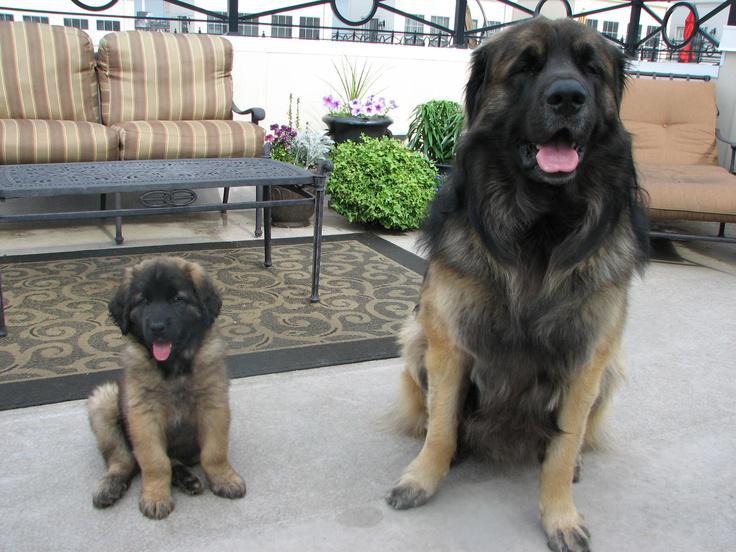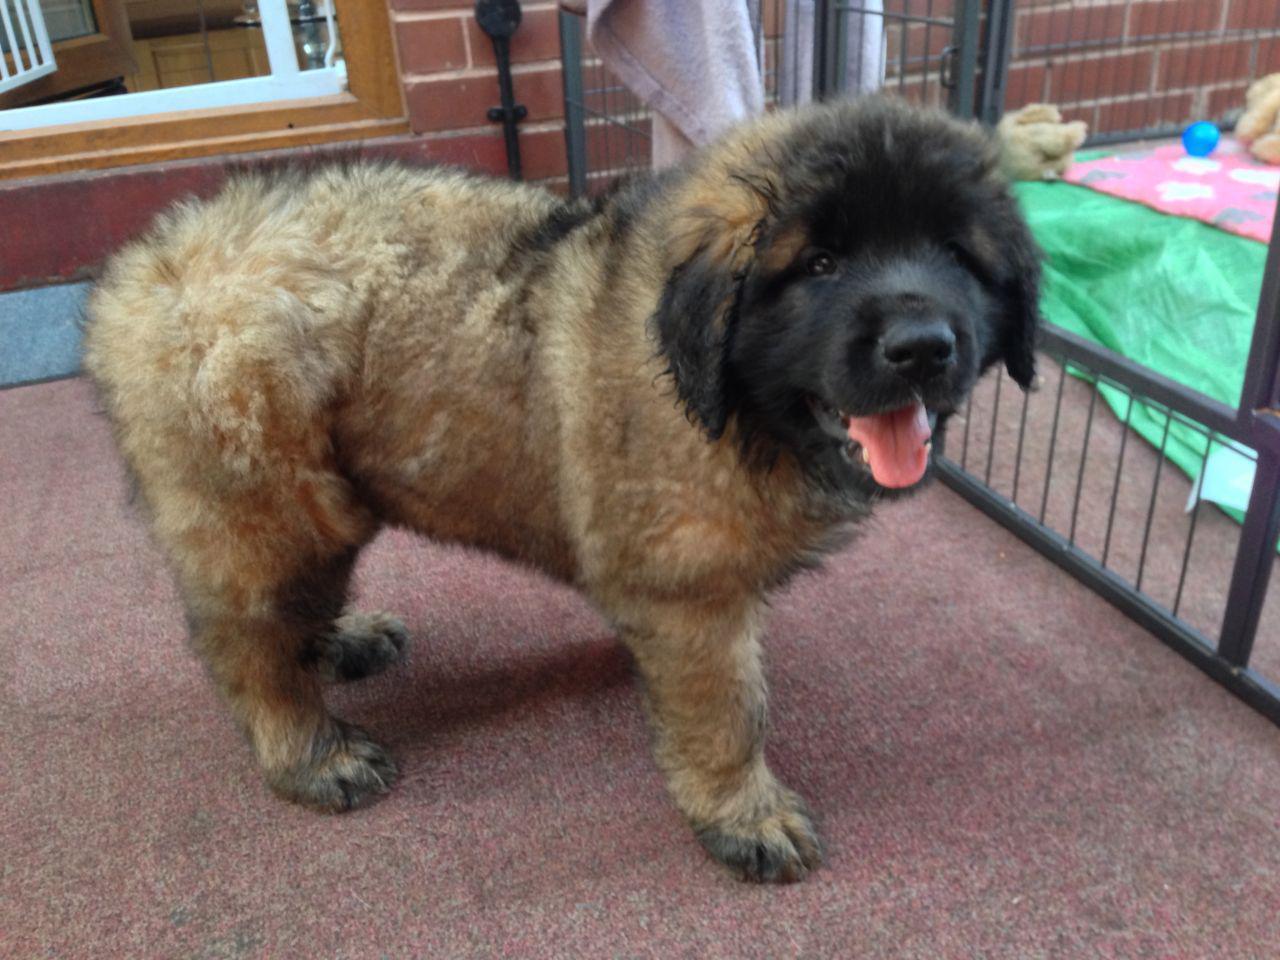The first image is the image on the left, the second image is the image on the right. Evaluate the accuracy of this statement regarding the images: "A human is petting a dog.". Is it true? Answer yes or no. No. 